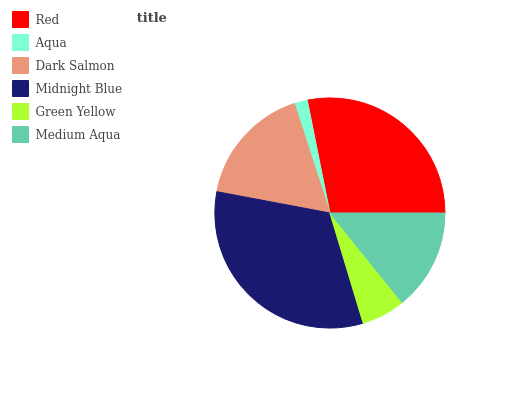Is Aqua the minimum?
Answer yes or no. Yes. Is Midnight Blue the maximum?
Answer yes or no. Yes. Is Dark Salmon the minimum?
Answer yes or no. No. Is Dark Salmon the maximum?
Answer yes or no. No. Is Dark Salmon greater than Aqua?
Answer yes or no. Yes. Is Aqua less than Dark Salmon?
Answer yes or no. Yes. Is Aqua greater than Dark Salmon?
Answer yes or no. No. Is Dark Salmon less than Aqua?
Answer yes or no. No. Is Dark Salmon the high median?
Answer yes or no. Yes. Is Medium Aqua the low median?
Answer yes or no. Yes. Is Medium Aqua the high median?
Answer yes or no. No. Is Green Yellow the low median?
Answer yes or no. No. 